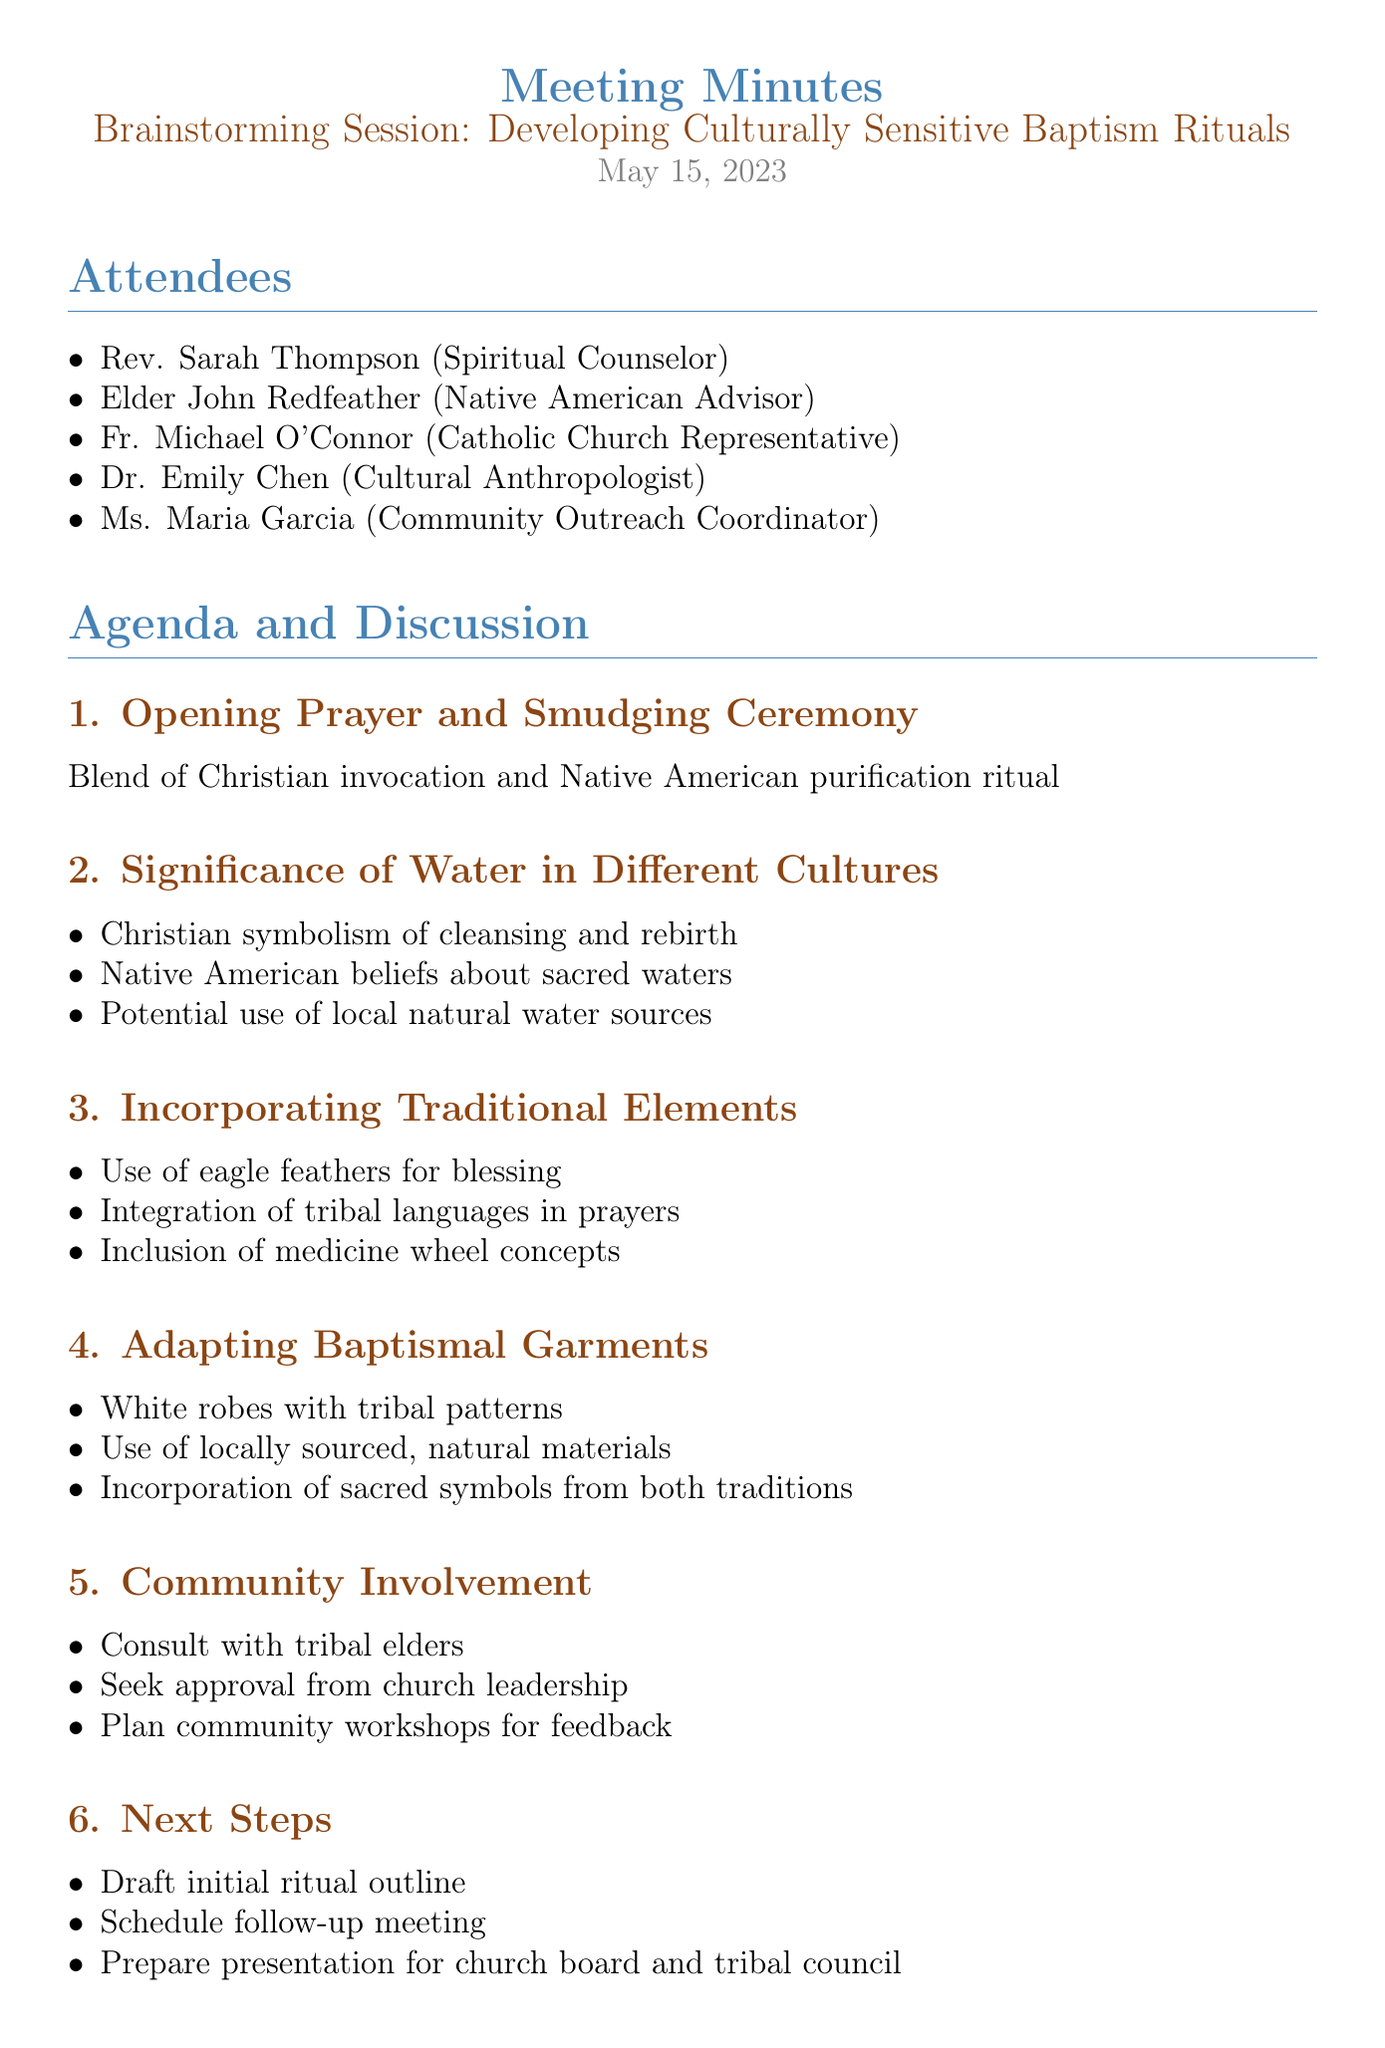What is the date of the meeting? The meeting is scheduled for May 15, 2023, as mentioned in the document.
Answer: May 15, 2023 Who is the Native American Advisor? The document lists Elder John Redfeather as the Native American Advisor.
Answer: Elder John Redfeather What is one traditional element proposed for incorporation? The document discusses the use of eagle feathers for blessing as a traditional element.
Answer: Use of eagle feathers for blessing What materials are suggested for baptismal garments? The suggestions include using locally sourced, natural materials for baptismal garments.
Answer: Locally sourced, natural materials What is the first task listed under Next Steps? The first task outlined in the Next Steps section is to draft the initial ritual outline.
Answer: Draft initial ritual outline Which community involvement action item seeks feedback? The plan for community workshops aims to seek feedback from the community, as indicated in the action items.
Answer: Plan community workshops for feedback What is one key outcome related to water usage? The document highlights the decision to use both holy water and water from a local sacred spring as a key outcome.
Answer: Both holy water and water from a local sacred spring How many attendees were present at the meeting? The attendee list includes five individuals, thus there are five attendees present at the meeting.
Answer: Five What is the main topic of the meeting? The meeting focuses on developing culturally sensitive baptism rituals, as stated in the title.
Answer: Developing Culturally Sensitive Baptism Rituals 